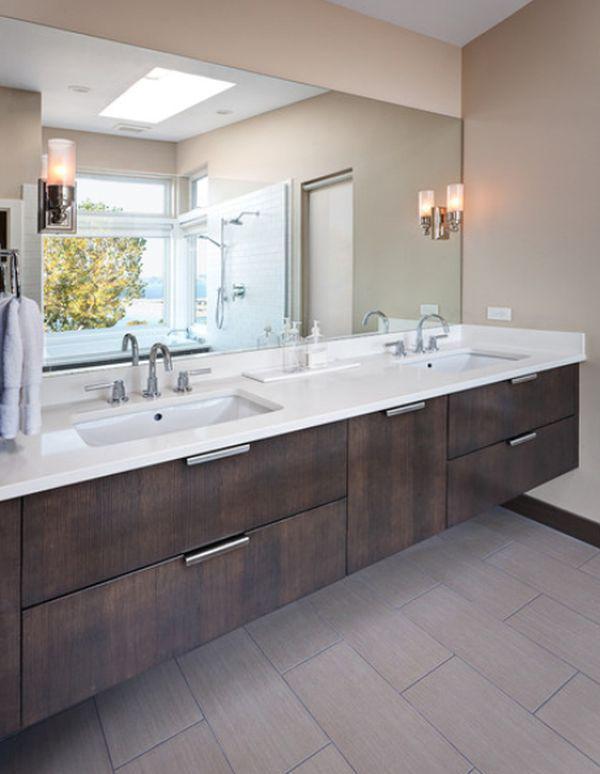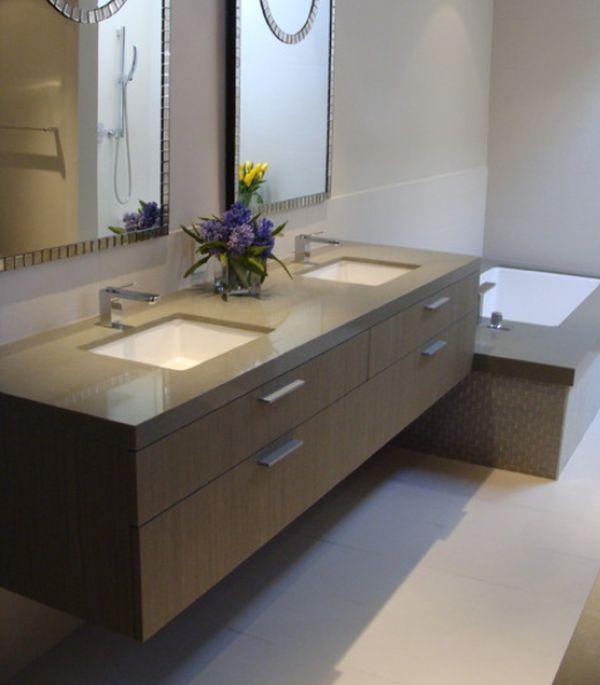The first image is the image on the left, the second image is the image on the right. Examine the images to the left and right. Is the description "An image includes a round white vessel sink." accurate? Answer yes or no. No. The first image is the image on the left, the second image is the image on the right. Analyze the images presented: Is the assertion "Vanities in both images have an equal number of sinks." valid? Answer yes or no. Yes. The first image is the image on the left, the second image is the image on the right. Evaluate the accuracy of this statement regarding the images: "There is a non-flowering plant sitting on the vanity.". Is it true? Answer yes or no. No. The first image is the image on the left, the second image is the image on the right. Assess this claim about the two images: "The right image features at least one round white bowl-shaped sink atop a vanity.". Correct or not? Answer yes or no. No. 